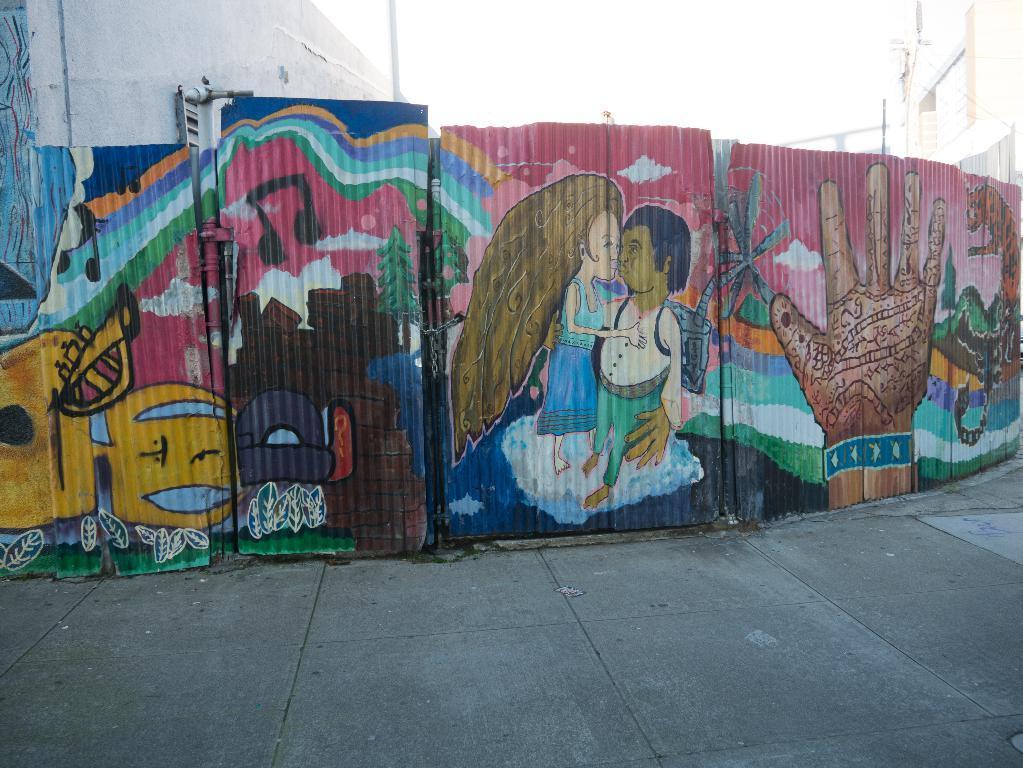Describe this image in one or two sentences. In this image I can see a wall on which I can see painting of people hand and some other cartoons. In the background I can see poles and the sky. 